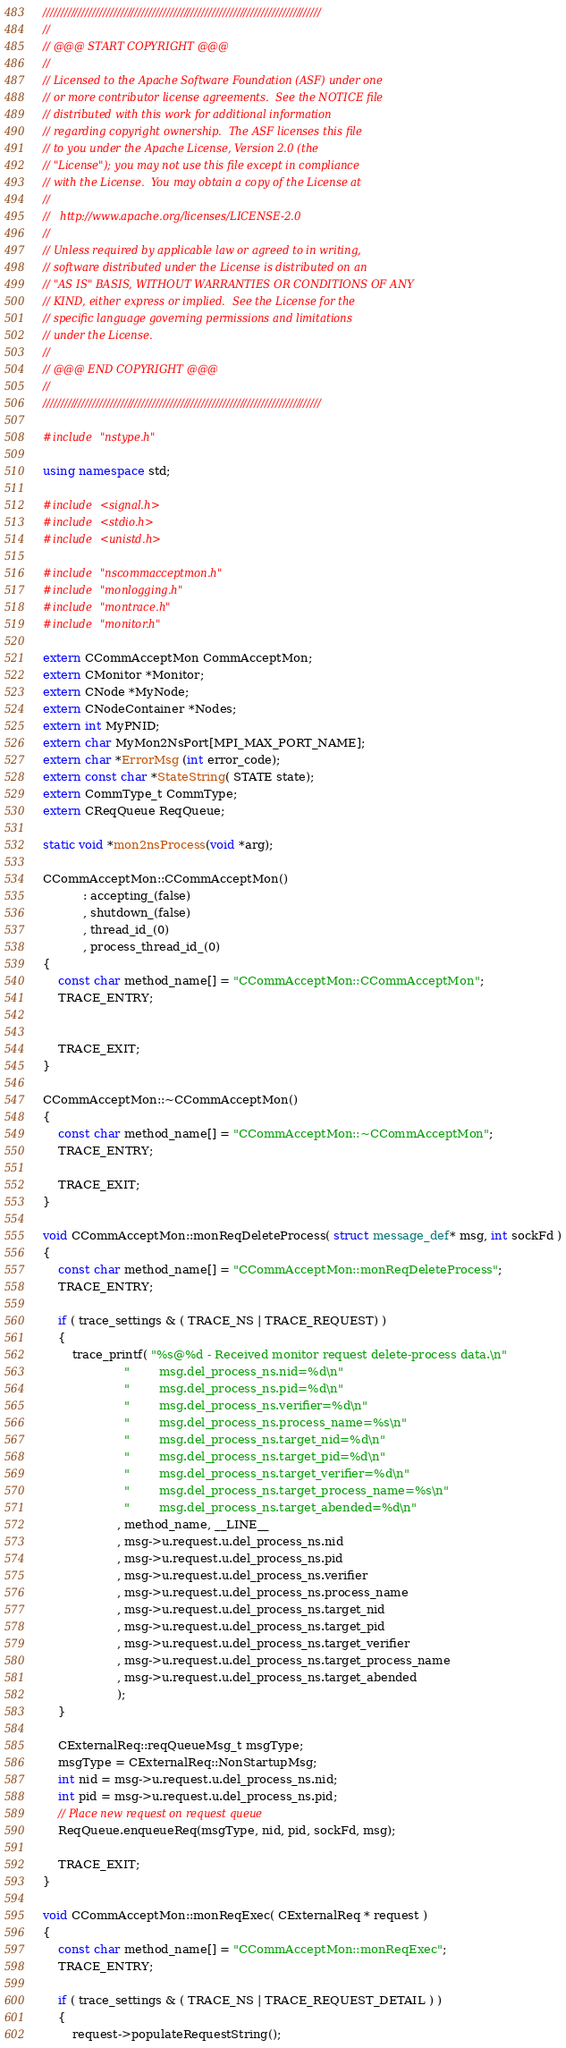Convert code to text. <code><loc_0><loc_0><loc_500><loc_500><_C++_>///////////////////////////////////////////////////////////////////////////////
//
// @@@ START COPYRIGHT @@@
//
// Licensed to the Apache Software Foundation (ASF) under one
// or more contributor license agreements.  See the NOTICE file
// distributed with this work for additional information
// regarding copyright ownership.  The ASF licenses this file
// to you under the Apache License, Version 2.0 (the
// "License"); you may not use this file except in compliance
// with the License.  You may obtain a copy of the License at
//
//   http://www.apache.org/licenses/LICENSE-2.0
//
// Unless required by applicable law or agreed to in writing,
// software distributed under the License is distributed on an
// "AS IS" BASIS, WITHOUT WARRANTIES OR CONDITIONS OF ANY
// KIND, either express or implied.  See the License for the
// specific language governing permissions and limitations
// under the License.
//
// @@@ END COPYRIGHT @@@
//
///////////////////////////////////////////////////////////////////////////////

#include "nstype.h"

using namespace std;

#include <signal.h>
#include <stdio.h>
#include <unistd.h>

#include "nscommacceptmon.h"
#include "monlogging.h"
#include "montrace.h"
#include "monitor.h"

extern CCommAcceptMon CommAcceptMon;
extern CMonitor *Monitor;
extern CNode *MyNode;
extern CNodeContainer *Nodes;
extern int MyPNID;
extern char MyMon2NsPort[MPI_MAX_PORT_NAME];
extern char *ErrorMsg (int error_code);
extern const char *StateString( STATE state);
extern CommType_t CommType;
extern CReqQueue ReqQueue;

static void *mon2nsProcess(void *arg);

CCommAcceptMon::CCommAcceptMon()
           : accepting_(false)
           , shutdown_(false)
           , thread_id_(0)
           , process_thread_id_(0)
{
    const char method_name[] = "CCommAcceptMon::CCommAcceptMon";
    TRACE_ENTRY;


    TRACE_EXIT;
}

CCommAcceptMon::~CCommAcceptMon()
{
    const char method_name[] = "CCommAcceptMon::~CCommAcceptMon";
    TRACE_ENTRY;

    TRACE_EXIT;
}

void CCommAcceptMon::monReqDeleteProcess( struct message_def* msg, int sockFd )
{
    const char method_name[] = "CCommAcceptMon::monReqDeleteProcess";
    TRACE_ENTRY;

    if ( trace_settings & ( TRACE_NS | TRACE_REQUEST) )
    {
        trace_printf( "%s@%d - Received monitor request delete-process data.\n"
                      "        msg.del_process_ns.nid=%d\n"
                      "        msg.del_process_ns.pid=%d\n"
                      "        msg.del_process_ns.verifier=%d\n"
                      "        msg.del_process_ns.process_name=%s\n"
                      "        msg.del_process_ns.target_nid=%d\n"
                      "        msg.del_process_ns.target_pid=%d\n"
                      "        msg.del_process_ns.target_verifier=%d\n"
                      "        msg.del_process_ns.target_process_name=%s\n"
                      "        msg.del_process_ns.target_abended=%d\n"
                    , method_name, __LINE__
                    , msg->u.request.u.del_process_ns.nid
                    , msg->u.request.u.del_process_ns.pid
                    , msg->u.request.u.del_process_ns.verifier
                    , msg->u.request.u.del_process_ns.process_name
                    , msg->u.request.u.del_process_ns.target_nid
                    , msg->u.request.u.del_process_ns.target_pid
                    , msg->u.request.u.del_process_ns.target_verifier
                    , msg->u.request.u.del_process_ns.target_process_name
                    , msg->u.request.u.del_process_ns.target_abended
                    );
    }

    CExternalReq::reqQueueMsg_t msgType;
    msgType = CExternalReq::NonStartupMsg;
    int nid = msg->u.request.u.del_process_ns.nid;
    int pid = msg->u.request.u.del_process_ns.pid;
    // Place new request on request queue
    ReqQueue.enqueueReq(msgType, nid, pid, sockFd, msg);

    TRACE_EXIT;
}

void CCommAcceptMon::monReqExec( CExternalReq * request )
{
    const char method_name[] = "CCommAcceptMon::monReqExec";
    TRACE_ENTRY;

    if ( trace_settings & ( TRACE_NS | TRACE_REQUEST_DETAIL ) )
    {
        request->populateRequestString();</code> 